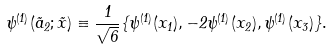Convert formula to latex. <formula><loc_0><loc_0><loc_500><loc_500>\psi ^ { ( 1 ) } ( \vec { a } _ { 2 } ; \vec { x } ) \equiv \frac { 1 } { \sqrt { 6 } } \{ \psi ^ { ( 1 ) } ( x _ { 1 } ) , - 2 \psi ^ { ( 1 ) } ( x _ { 2 } ) , \psi ^ { ( 1 ) } ( x _ { 3 } ) \} .</formula> 